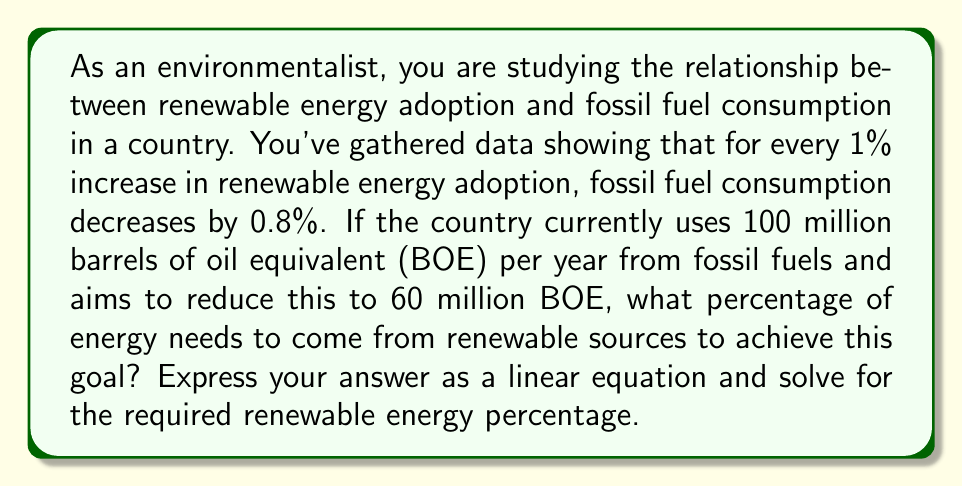Teach me how to tackle this problem. Let's approach this step-by-step:

1) Let $x$ be the percentage increase in renewable energy adoption.
2) Let $y$ be the reduction in fossil fuel consumption in million BOE.

Given:
- For every 1% increase in renewable energy, fossil fuel consumption decreases by 0.8%.
- Current fossil fuel consumption is 100 million BOE.
- Target fossil fuel consumption is 60 million BOE.

We can express this as a linear equation:

$$y = 0.8x$$

The total reduction needed is:

$$y = 100 - 60 = 40$$ million BOE

Substituting this into our equation:

$$40 = 0.8x$$

To solve for $x$, we divide both sides by 0.8:

$$x = 40 ÷ 0.8 = 50$$

Therefore, renewable energy adoption needs to increase by 50% to achieve the target reduction in fossil fuel consumption.

To express this as a linear equation relating renewable energy percentage ($R$) to fossil fuel consumption ($F$) in million BOE:

$$F = 100 - 0.8R$$

Where $R$ is the percentage of renewable energy adoption, and 100 is the initial fossil fuel consumption.
Answer: The required increase in renewable energy adoption is 50%. The linear equation relating renewable energy percentage ($R$) to fossil fuel consumption ($F$) in million BOE is:

$$F = 100 - 0.8R$$

When $R = 50$, $F = 60$ million BOE, achieving the target reduction. 